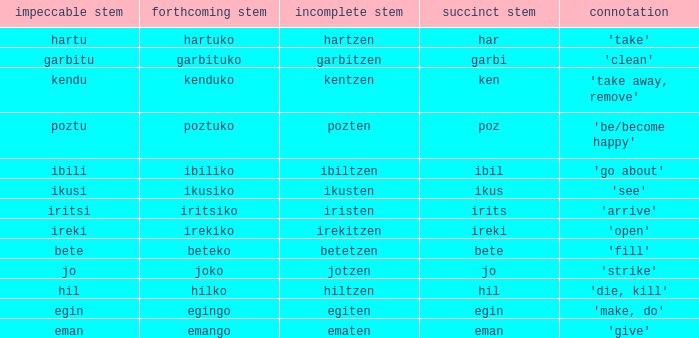What is the number for future stem for poztu? 1.0. 